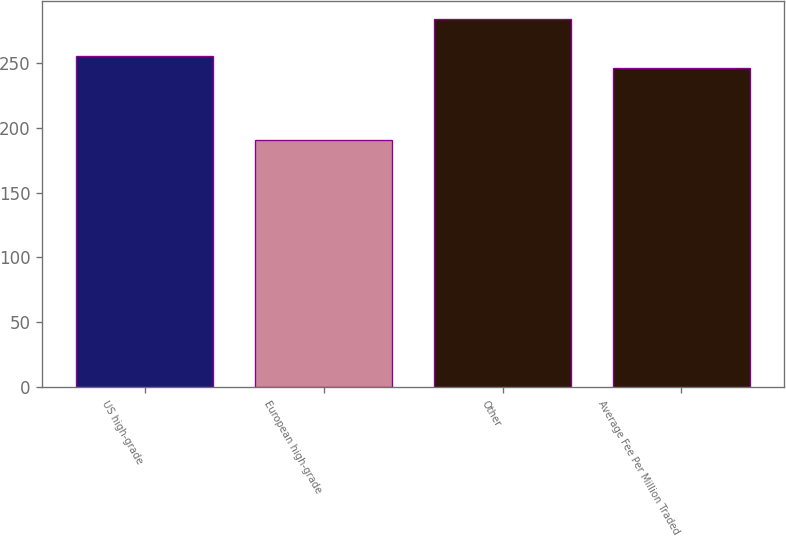Convert chart to OTSL. <chart><loc_0><loc_0><loc_500><loc_500><bar_chart><fcel>US high-grade<fcel>European high-grade<fcel>Other<fcel>Average Fee Per Million Traded<nl><fcel>255.6<fcel>191<fcel>284<fcel>246.3<nl></chart> 